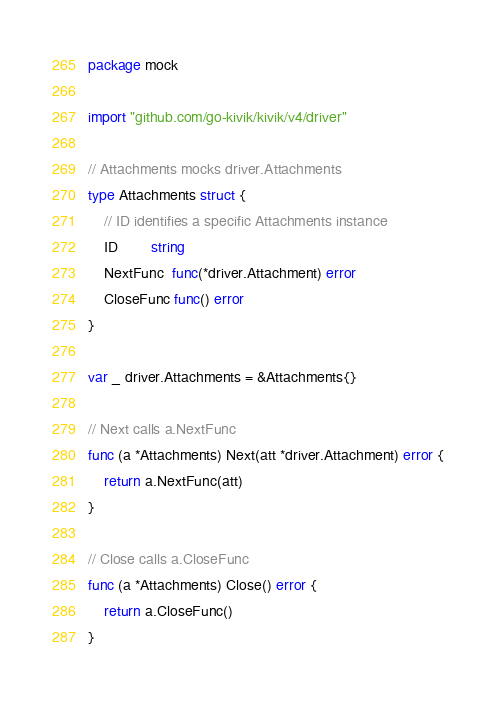Convert code to text. <code><loc_0><loc_0><loc_500><loc_500><_Go_>package mock

import "github.com/go-kivik/kivik/v4/driver"

// Attachments mocks driver.Attachments
type Attachments struct {
	// ID identifies a specific Attachments instance
	ID        string
	NextFunc  func(*driver.Attachment) error
	CloseFunc func() error
}

var _ driver.Attachments = &Attachments{}

// Next calls a.NextFunc
func (a *Attachments) Next(att *driver.Attachment) error {
	return a.NextFunc(att)
}

// Close calls a.CloseFunc
func (a *Attachments) Close() error {
	return a.CloseFunc()
}
</code> 